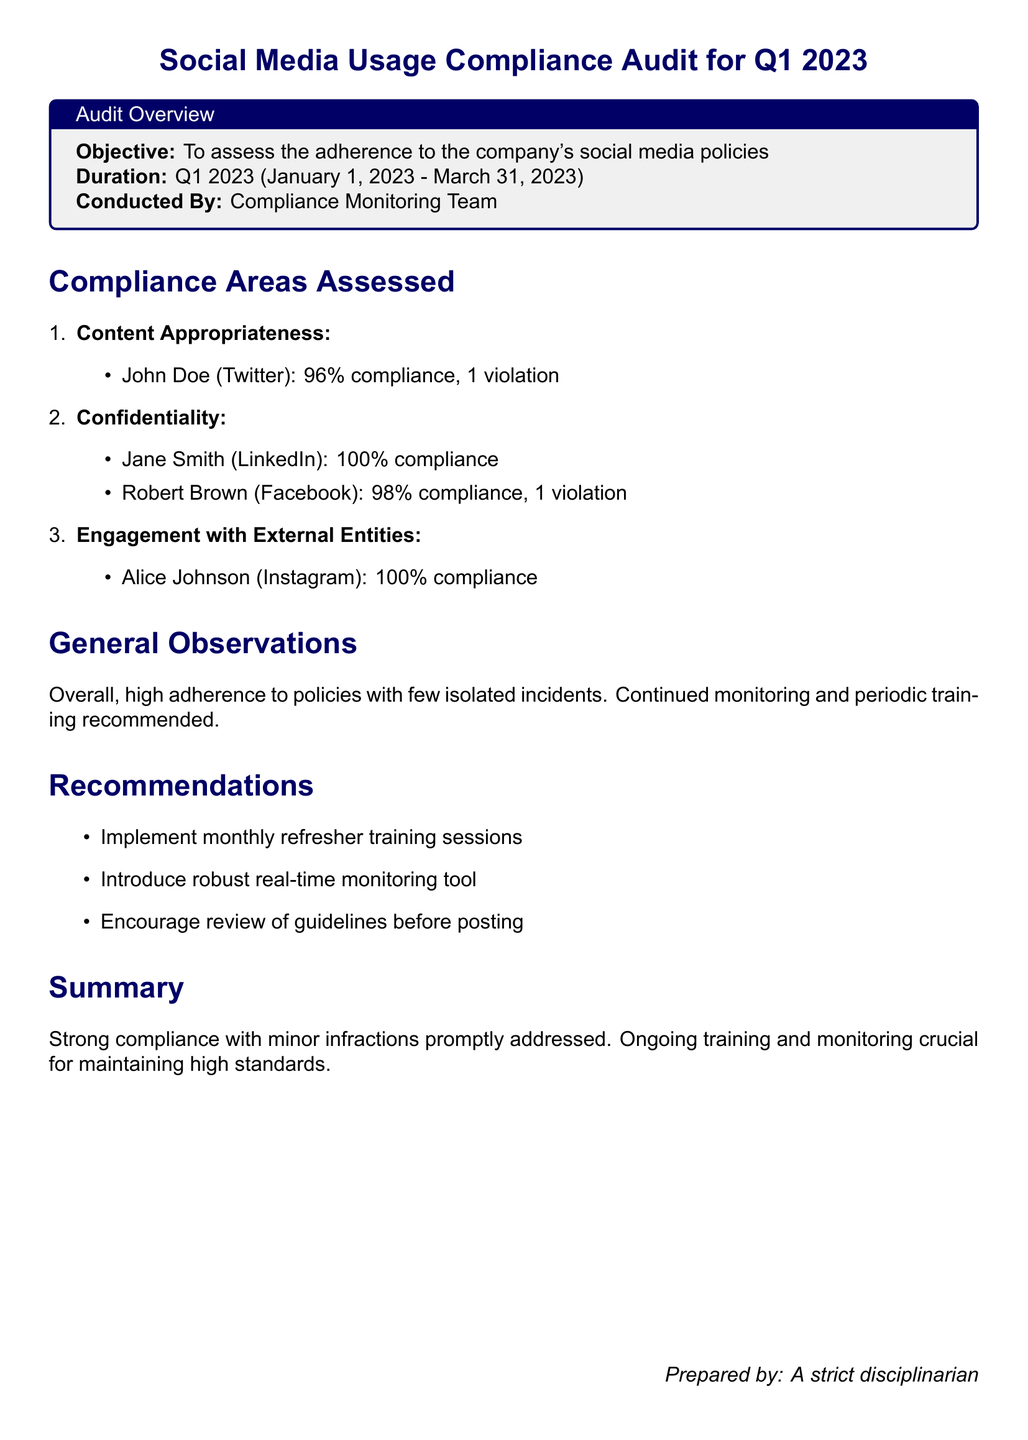What is the objective of the audit? The objective is to assess the adherence to the company's social media policies.
Answer: To assess the adherence to the company's social media policies What was the compliance percentage for John Doe on Twitter? The compliance percentage for John Doe on Twitter is stated in the document.
Answer: 96% How many violations did Robert Brown have on Facebook? The document specifies the number of violations for Robert Brown.
Answer: 1 violation What was the compliance percentage for Jane Smith on LinkedIn? The document provides the compliance percentage for Jane Smith on LinkedIn.
Answer: 100% What recommendation involves training sessions? The recommendation is mentioned specifically in relation to training.
Answer: Monthly refresher training sessions What is the total duration of the audit period? The duration is clearly defined in the overview section of the document.
Answer: Q1 2023 (January 1, 2023 - March 31, 2023) How many people were assessed in the content appropriateness category? The document implies the number of individuals assessed in this compliance area.
Answer: 1 (John Doe) What does the document recommend to encourage compliance? The document lists specific recommendations for improving compliance.
Answer: Review of guidelines before posting 